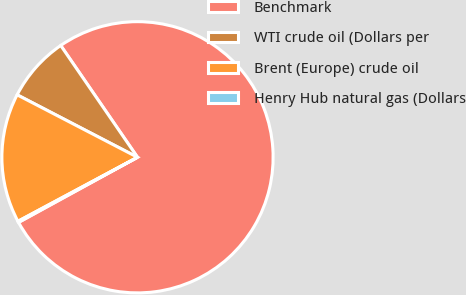Convert chart. <chart><loc_0><loc_0><loc_500><loc_500><pie_chart><fcel>Benchmark<fcel>WTI crude oil (Dollars per<fcel>Brent (Europe) crude oil<fcel>Henry Hub natural gas (Dollars<nl><fcel>76.6%<fcel>7.8%<fcel>15.44%<fcel>0.15%<nl></chart> 